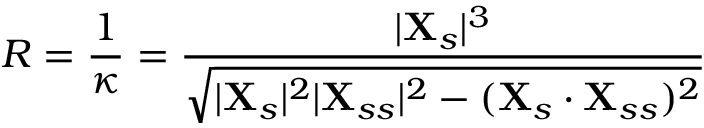Convert formula to latex. <formula><loc_0><loc_0><loc_500><loc_500>R = \frac { 1 } { \kappa } = \frac { | X _ { s } | ^ { 3 } } { \sqrt { | X _ { s } | ^ { 2 } | X _ { s s } | ^ { 2 } - ( X _ { s } \cdot X _ { s s } ) ^ { 2 } } }</formula> 